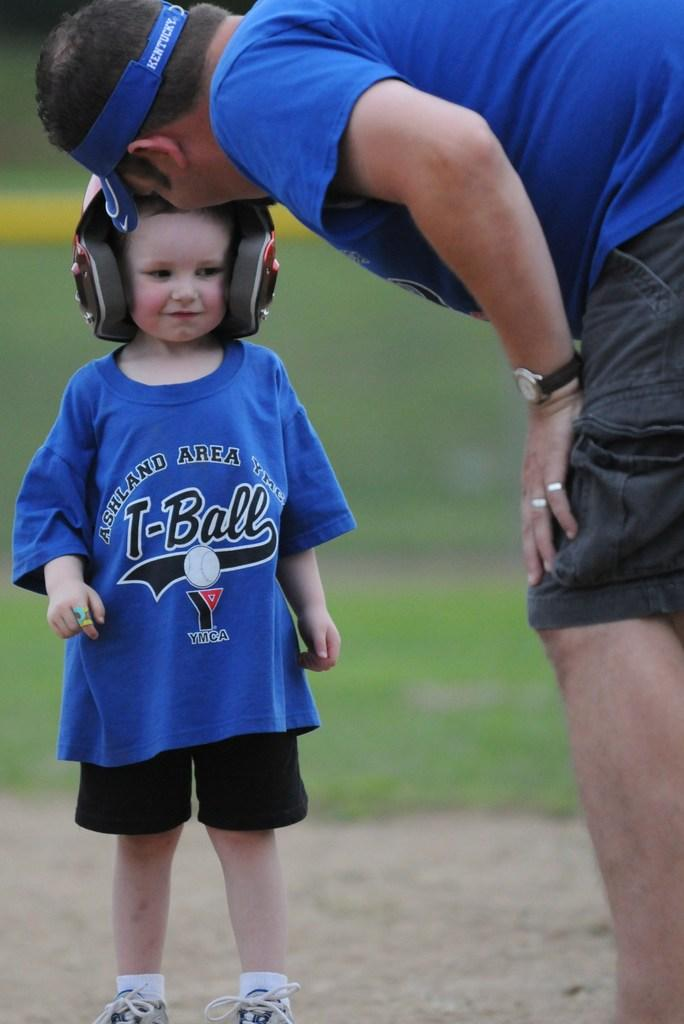<image>
Share a concise interpretation of the image provided. A young T-ball player sponsored by Ashland Area YMCA gets some advice from a coach. 